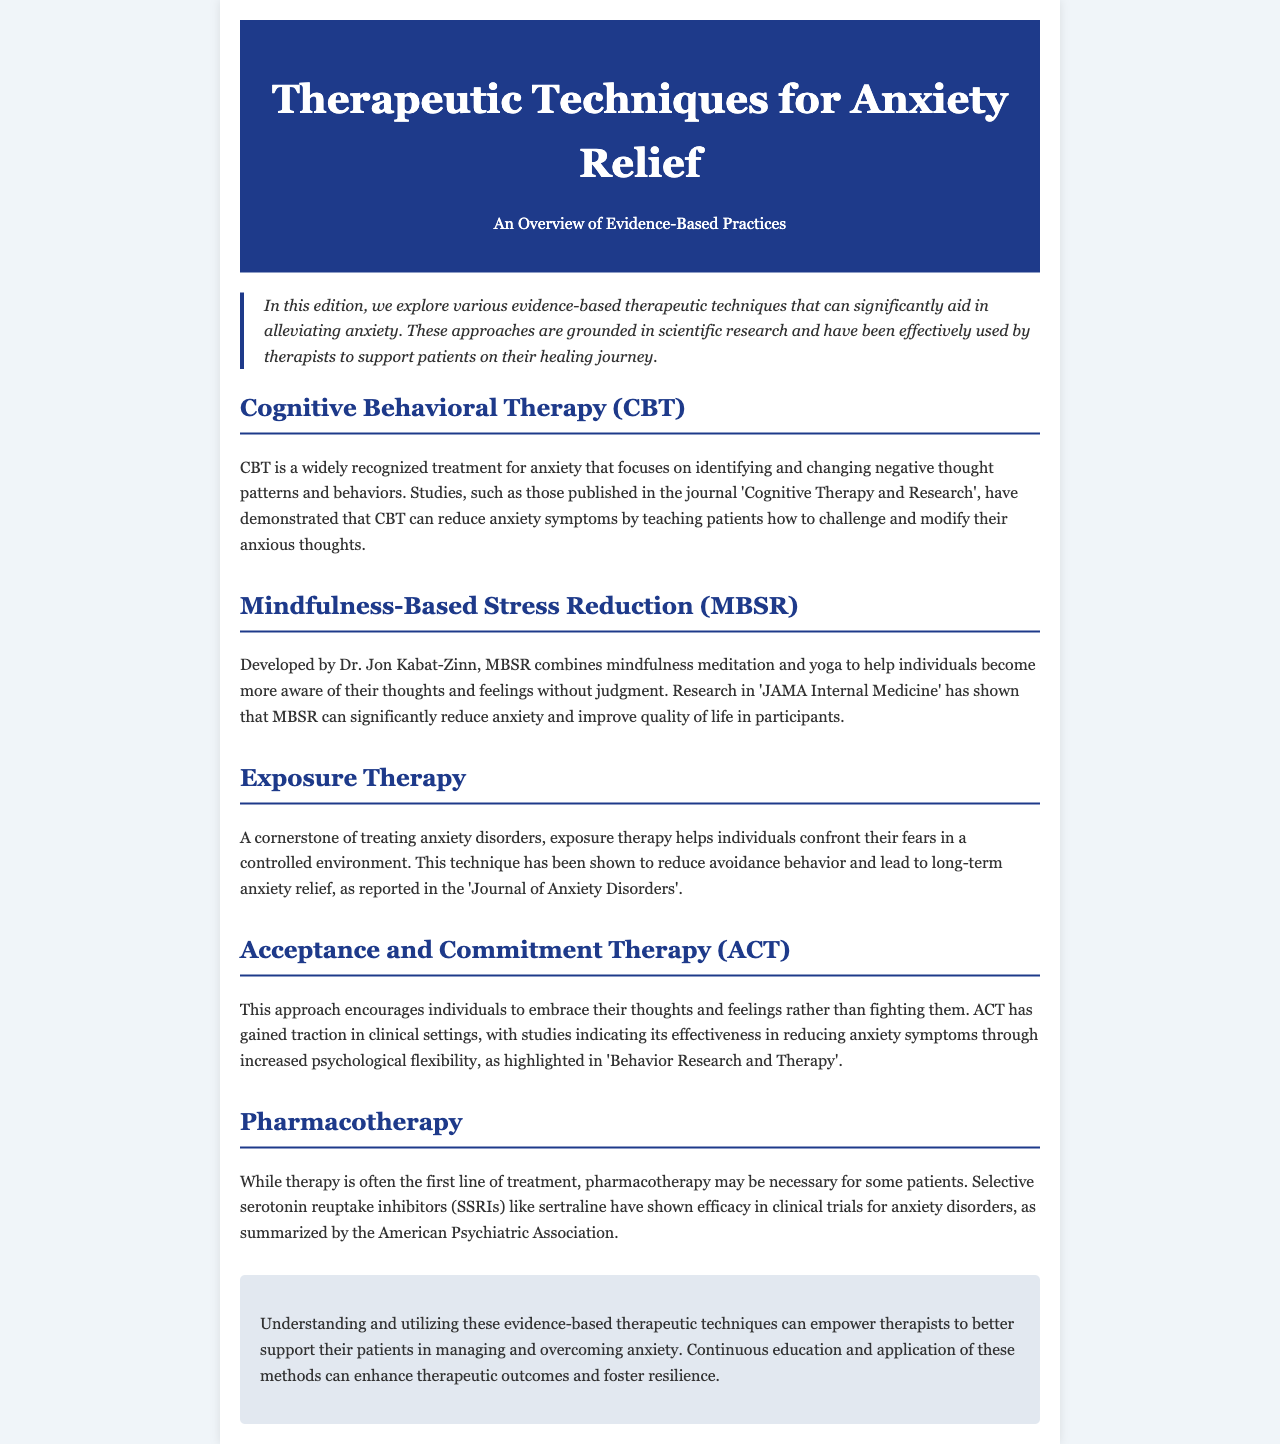What is the title of the newsletter? The title of the newsletter is mentioned in the header section of the document.
Answer: Therapeutic Techniques for Anxiety Relief Who developed Mindfulness-Based Stress Reduction? The developer of Mindfulness-Based Stress Reduction is explicitly stated in the document.
Answer: Dr. Jon Kabat-Zinn Which therapy focuses on identifying and changing negative thought patterns? The document describes specific therapeutic techniques, including one that focuses on modifying thought patterns.
Answer: Cognitive Behavioral Therapy (CBT) What is a cornerstone treatment for anxiety disorders mentioned in the newsletter? The document categorically identifies a specific treatment technique as fundamental for anxiety disorders.
Answer: Exposure Therapy What journal published the research indicating the efficacy of Acceptance and Commitment Therapy? The document specifies the source where the effectiveness of ACT is highlighted.
Answer: Behavior Research and Therapy How does Acceptance and Commitment Therapy help individuals? The document describes the effects and goals of Acceptance and Commitment Therapy in a summarized manner.
Answer: Increased psychological flexibility What techniques does Mindfulness-Based Stress Reduction combine? The document outlines what elements are involved in Mindfulness-Based Stress Reduction.
Answer: Mindfulness meditation and yoga What type of medication is mentioned under Pharmacotherapy? The document lists a specific class of medication used in treating anxiety disorders.
Answer: Selective serotonin reuptake inhibitors (SSRIs) What outcome does Exposure Therapy aim to achieve? The document details the objectives of Exposure Therapy concerning anxiety relief.
Answer: Long-term anxiety relief 